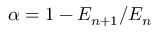<formula> <loc_0><loc_0><loc_500><loc_500>\alpha = 1 - E _ { n + 1 } / E _ { n }</formula> 